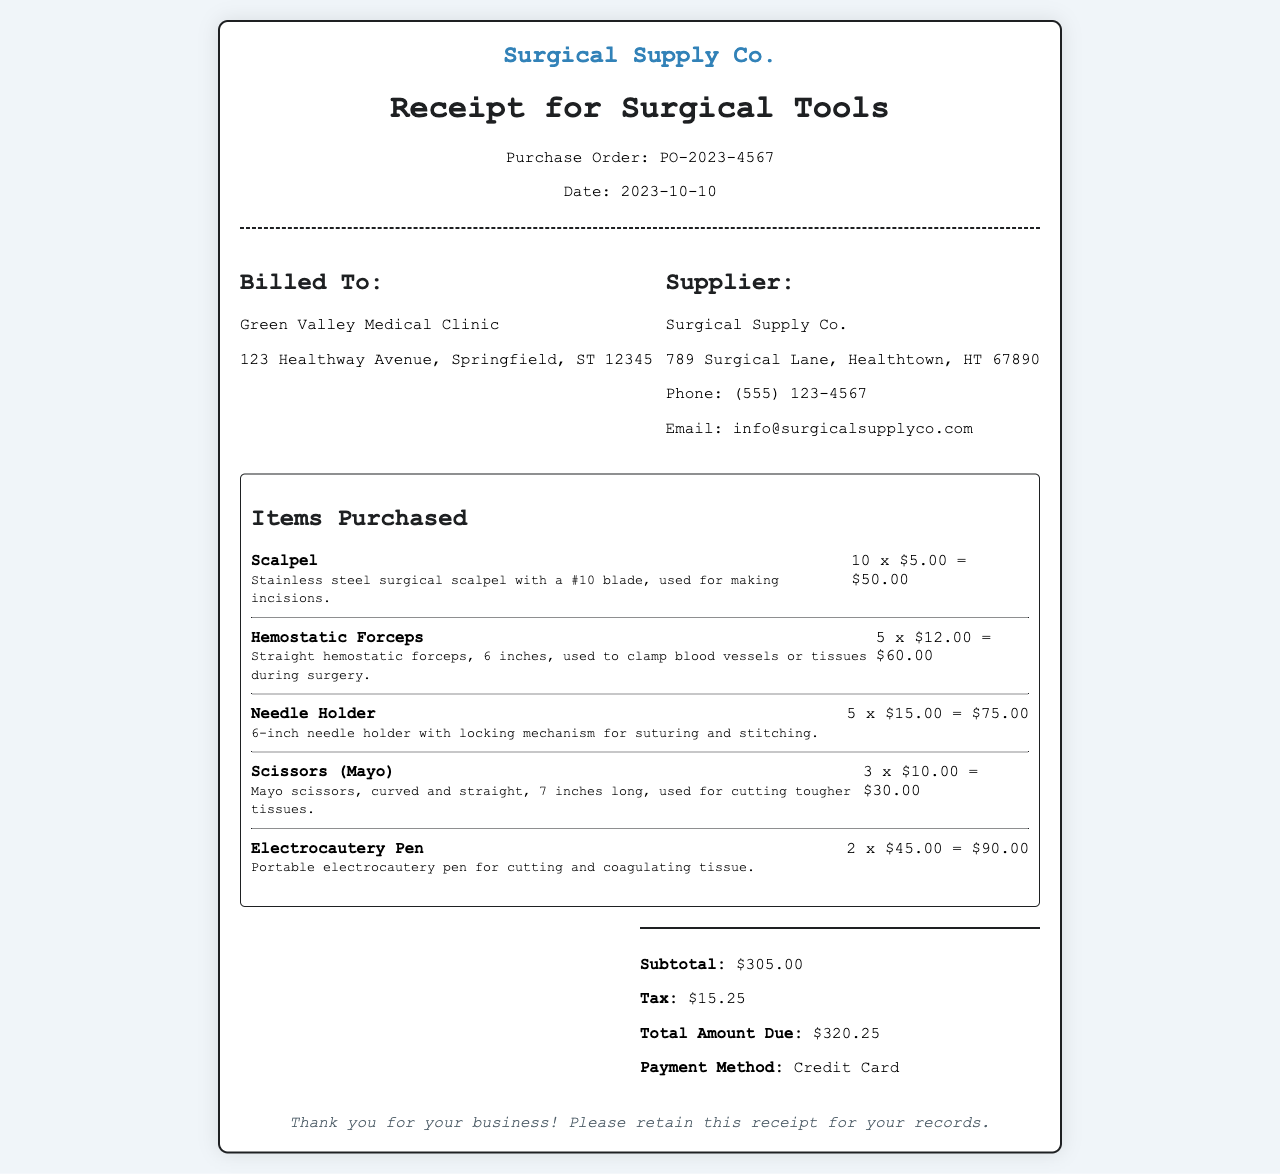What is the purchase order number? The purchase order number is specifically listed in the document, which is PO-2023-4567.
Answer: PO-2023-4567 What is the date of the receipt? The date is explicitly mentioned in the document as the date the purchase was made.
Answer: 2023-10-10 Who is billed for the surgical tools? The recipient of the bill is clearly indicated in the document under the "Billed To" section.
Answer: Green Valley Medical Clinic What is the subtotal amount? The subtotal amount totals the items purchased before tax, as shown in the summary section.
Answer: $305.00 How many hemostatic forceps were purchased? The quantity of hemostatic forceps is provided next to the item description in the document.
Answer: 5 What is the total amount due? The total amount due is clearly displayed in the summary details section of the receipt.
Answer: $320.25 What is the method of payment? The method of payment used is mentioned at the end of the summary section.
Answer: Credit Card What type of scalpel is included? The specific type of scalpel is described in detail accompanying its purchase listing in the document.
Answer: Stainless steel surgical scalpel with a #10 blade How many electrocautery pens were ordered? The number of electrocautery pens purchased is indicated next to the item in the list.
Answer: 2 What is the supplier's email address? The supplier's email address is listed in the contact information section of the document.
Answer: info@surgicalsupplyco.com 